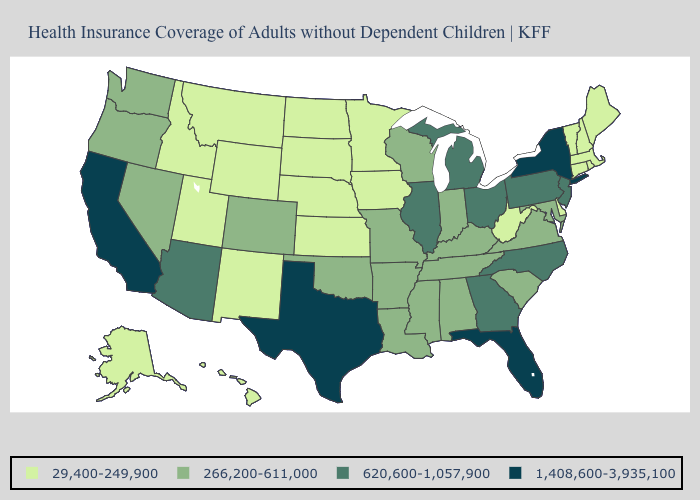Does Nevada have the highest value in the West?
Give a very brief answer. No. What is the value of Iowa?
Be succinct. 29,400-249,900. What is the value of Wisconsin?
Quick response, please. 266,200-611,000. Name the states that have a value in the range 266,200-611,000?
Write a very short answer. Alabama, Arkansas, Colorado, Indiana, Kentucky, Louisiana, Maryland, Mississippi, Missouri, Nevada, Oklahoma, Oregon, South Carolina, Tennessee, Virginia, Washington, Wisconsin. Among the states that border South Carolina , which have the lowest value?
Answer briefly. Georgia, North Carolina. What is the highest value in the Northeast ?
Give a very brief answer. 1,408,600-3,935,100. Name the states that have a value in the range 620,600-1,057,900?
Give a very brief answer. Arizona, Georgia, Illinois, Michigan, New Jersey, North Carolina, Ohio, Pennsylvania. What is the value of Tennessee?
Answer briefly. 266,200-611,000. Does North Dakota have the lowest value in the USA?
Give a very brief answer. Yes. Among the states that border Florida , which have the highest value?
Be succinct. Georgia. Name the states that have a value in the range 29,400-249,900?
Answer briefly. Alaska, Connecticut, Delaware, Hawaii, Idaho, Iowa, Kansas, Maine, Massachusetts, Minnesota, Montana, Nebraska, New Hampshire, New Mexico, North Dakota, Rhode Island, South Dakota, Utah, Vermont, West Virginia, Wyoming. Does Virginia have the same value as Pennsylvania?
Keep it brief. No. Among the states that border Arizona , does Utah have the lowest value?
Answer briefly. Yes. Does Rhode Island have the highest value in the USA?
Write a very short answer. No. Which states have the highest value in the USA?
Answer briefly. California, Florida, New York, Texas. 